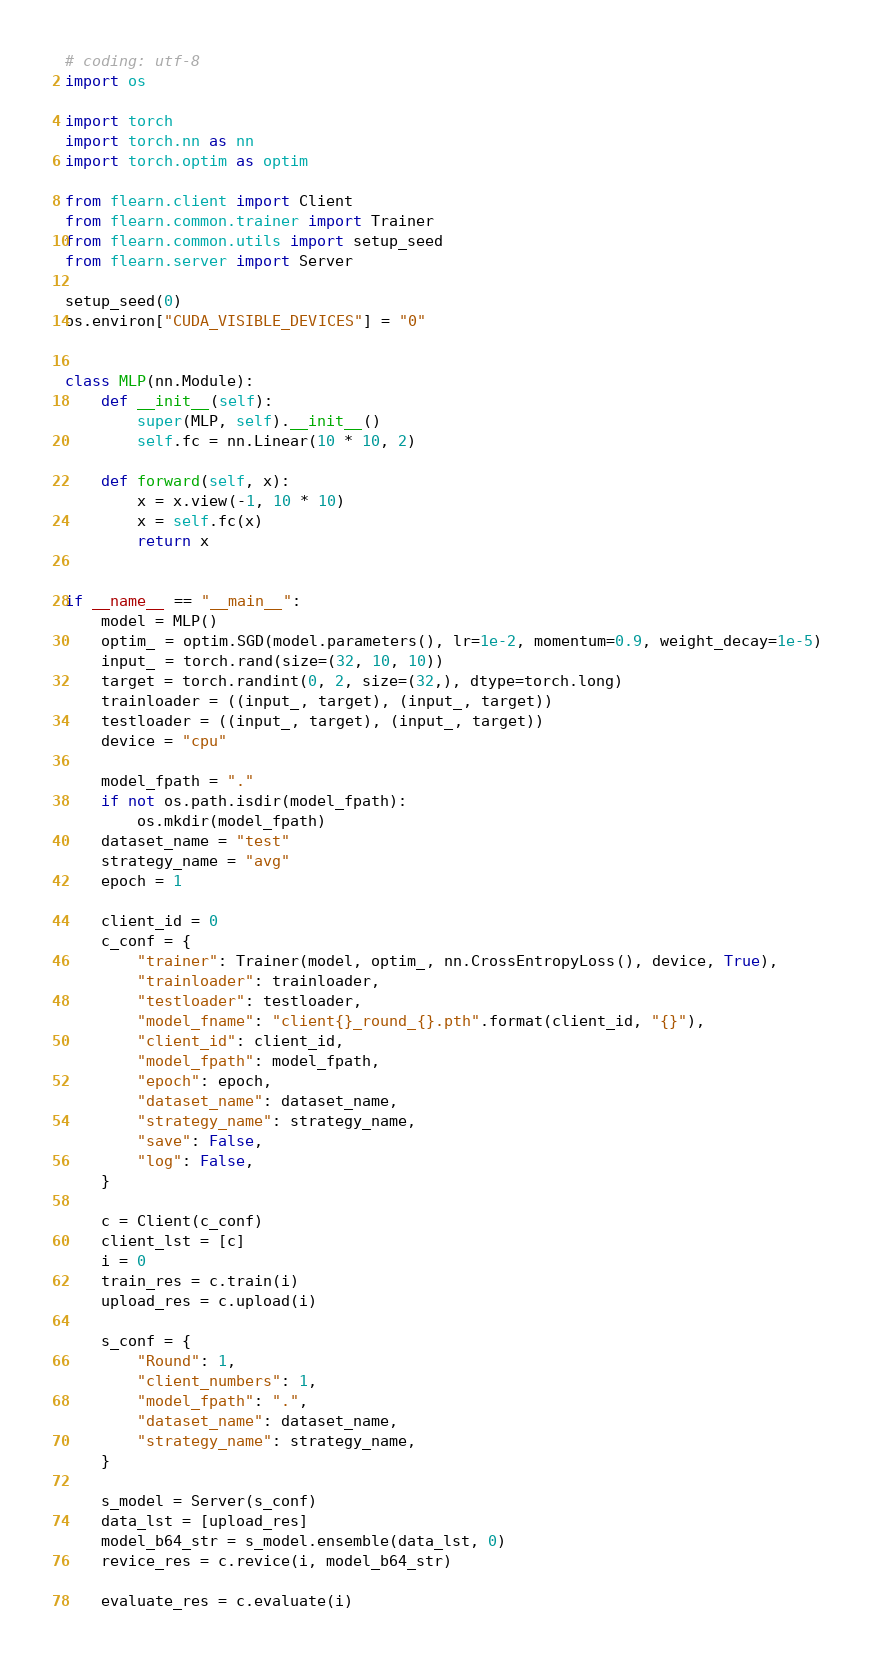Convert code to text. <code><loc_0><loc_0><loc_500><loc_500><_Python_># coding: utf-8
import os

import torch
import torch.nn as nn
import torch.optim as optim

from flearn.client import Client
from flearn.common.trainer import Trainer
from flearn.common.utils import setup_seed
from flearn.server import Server

setup_seed(0)
os.environ["CUDA_VISIBLE_DEVICES"] = "0"


class MLP(nn.Module):
    def __init__(self):
        super(MLP, self).__init__()
        self.fc = nn.Linear(10 * 10, 2)

    def forward(self, x):
        x = x.view(-1, 10 * 10)
        x = self.fc(x)
        return x


if __name__ == "__main__":
    model = MLP()
    optim_ = optim.SGD(model.parameters(), lr=1e-2, momentum=0.9, weight_decay=1e-5)
    input_ = torch.rand(size=(32, 10, 10))
    target = torch.randint(0, 2, size=(32,), dtype=torch.long)
    trainloader = ((input_, target), (input_, target))
    testloader = ((input_, target), (input_, target))
    device = "cpu"

    model_fpath = "."
    if not os.path.isdir(model_fpath):
        os.mkdir(model_fpath)
    dataset_name = "test"
    strategy_name = "avg"
    epoch = 1

    client_id = 0
    c_conf = {
        "trainer": Trainer(model, optim_, nn.CrossEntropyLoss(), device, True),
        "trainloader": trainloader,
        "testloader": testloader,
        "model_fname": "client{}_round_{}.pth".format(client_id, "{}"),
        "client_id": client_id,
        "model_fpath": model_fpath,
        "epoch": epoch,
        "dataset_name": dataset_name,
        "strategy_name": strategy_name,
        "save": False,
        "log": False,
    }

    c = Client(c_conf)
    client_lst = [c]
    i = 0
    train_res = c.train(i)
    upload_res = c.upload(i)

    s_conf = {
        "Round": 1,
        "client_numbers": 1,
        "model_fpath": ".",
        "dataset_name": dataset_name,
        "strategy_name": strategy_name,
    }

    s_model = Server(s_conf)
    data_lst = [upload_res]
    model_b64_str = s_model.ensemble(data_lst, 0)
    revice_res = c.revice(i, model_b64_str)

    evaluate_res = c.evaluate(i)
</code> 